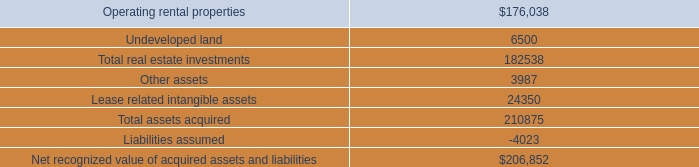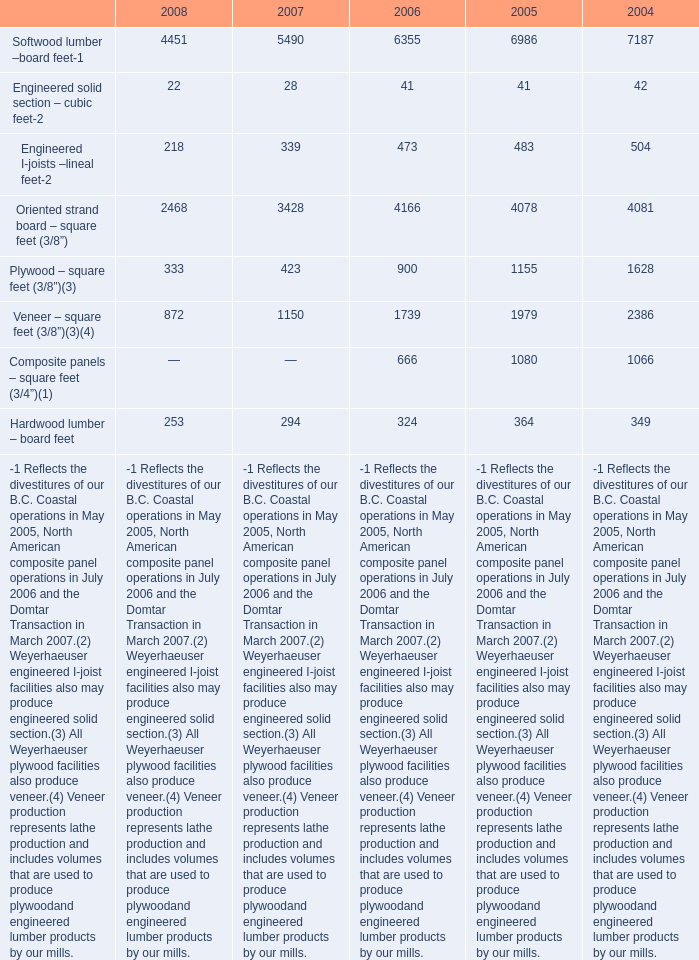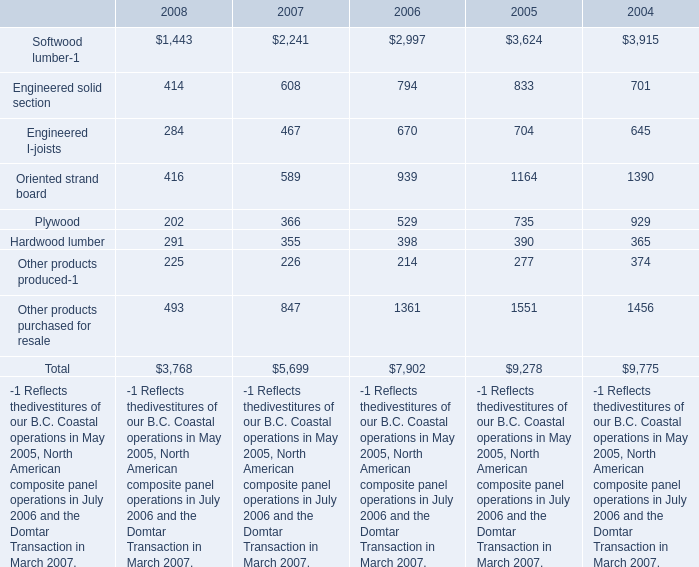How many elements' value in 2008 are lower than the previous year 
Answer: 9. 